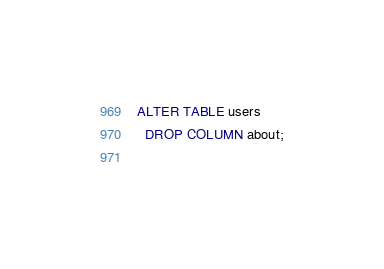<code> <loc_0><loc_0><loc_500><loc_500><_SQL_>ALTER TABLE users
  DROP COLUMN about;
  </code> 